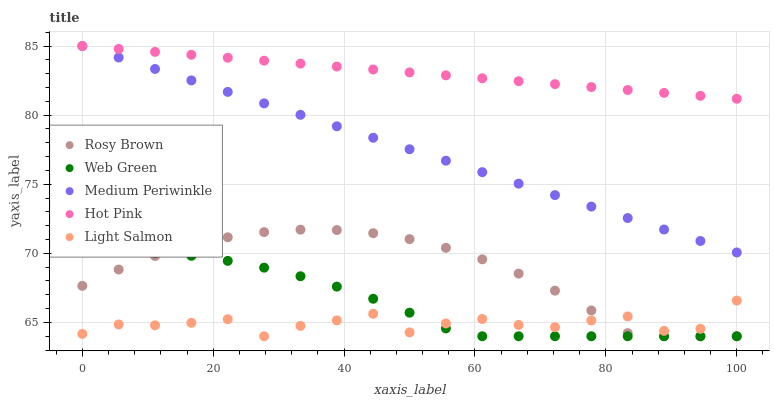Does Light Salmon have the minimum area under the curve?
Answer yes or no. Yes. Does Hot Pink have the maximum area under the curve?
Answer yes or no. Yes. Does Rosy Brown have the minimum area under the curve?
Answer yes or no. No. Does Rosy Brown have the maximum area under the curve?
Answer yes or no. No. Is Hot Pink the smoothest?
Answer yes or no. Yes. Is Light Salmon the roughest?
Answer yes or no. Yes. Is Rosy Brown the smoothest?
Answer yes or no. No. Is Rosy Brown the roughest?
Answer yes or no. No. Does Light Salmon have the lowest value?
Answer yes or no. Yes. Does Medium Periwinkle have the lowest value?
Answer yes or no. No. Does Hot Pink have the highest value?
Answer yes or no. Yes. Does Rosy Brown have the highest value?
Answer yes or no. No. Is Light Salmon less than Hot Pink?
Answer yes or no. Yes. Is Hot Pink greater than Web Green?
Answer yes or no. Yes. Does Light Salmon intersect Web Green?
Answer yes or no. Yes. Is Light Salmon less than Web Green?
Answer yes or no. No. Is Light Salmon greater than Web Green?
Answer yes or no. No. Does Light Salmon intersect Hot Pink?
Answer yes or no. No. 